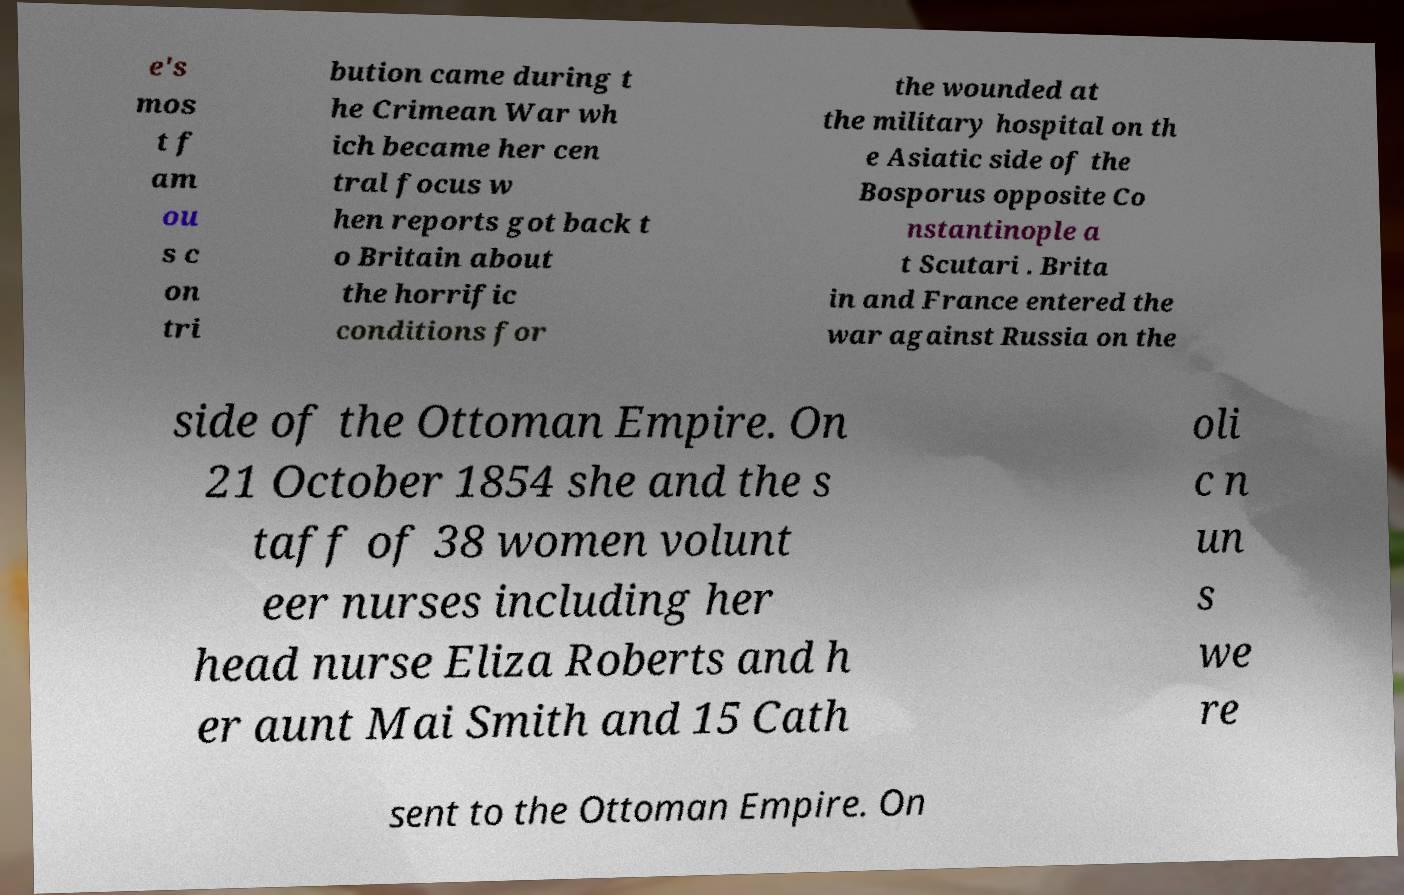For documentation purposes, I need the text within this image transcribed. Could you provide that? e's mos t f am ou s c on tri bution came during t he Crimean War wh ich became her cen tral focus w hen reports got back t o Britain about the horrific conditions for the wounded at the military hospital on th e Asiatic side of the Bosporus opposite Co nstantinople a t Scutari . Brita in and France entered the war against Russia on the side of the Ottoman Empire. On 21 October 1854 she and the s taff of 38 women volunt eer nurses including her head nurse Eliza Roberts and h er aunt Mai Smith and 15 Cath oli c n un s we re sent to the Ottoman Empire. On 